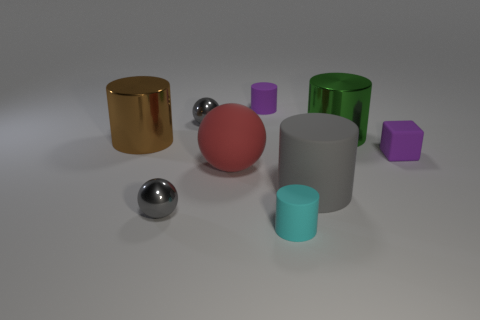Is the number of gray rubber cylinders that are behind the large brown shiny object the same as the number of big metallic cylinders?
Your response must be concise. No. There is a gray thing that is the same shape as the cyan rubber object; what size is it?
Provide a succinct answer. Large. There is a large green metallic object; is it the same shape as the gray object on the right side of the large rubber sphere?
Your answer should be compact. Yes. What is the size of the purple object that is on the left side of the purple matte object on the right side of the cyan matte thing?
Keep it short and to the point. Small. Is the number of red matte objects behind the large green cylinder the same as the number of big brown objects in front of the red matte object?
Keep it short and to the point. Yes. What is the color of the other metallic object that is the same shape as the green metal thing?
Your response must be concise. Brown. How many big objects have the same color as the big rubber sphere?
Keep it short and to the point. 0. There is a small gray object in front of the big matte sphere; is it the same shape as the big green metal thing?
Your answer should be compact. No. The tiny gray shiny thing that is in front of the big red matte sphere on the right side of the big shiny object left of the matte sphere is what shape?
Your response must be concise. Sphere. What is the size of the purple rubber cube?
Offer a terse response. Small. 